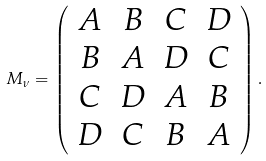<formula> <loc_0><loc_0><loc_500><loc_500>M _ { \nu } = \left ( \begin{array} { c c c c } A & B & C & D \\ B & A & D & C \\ C & D & A & B \\ D & C & B & A \end{array} \right ) .</formula> 